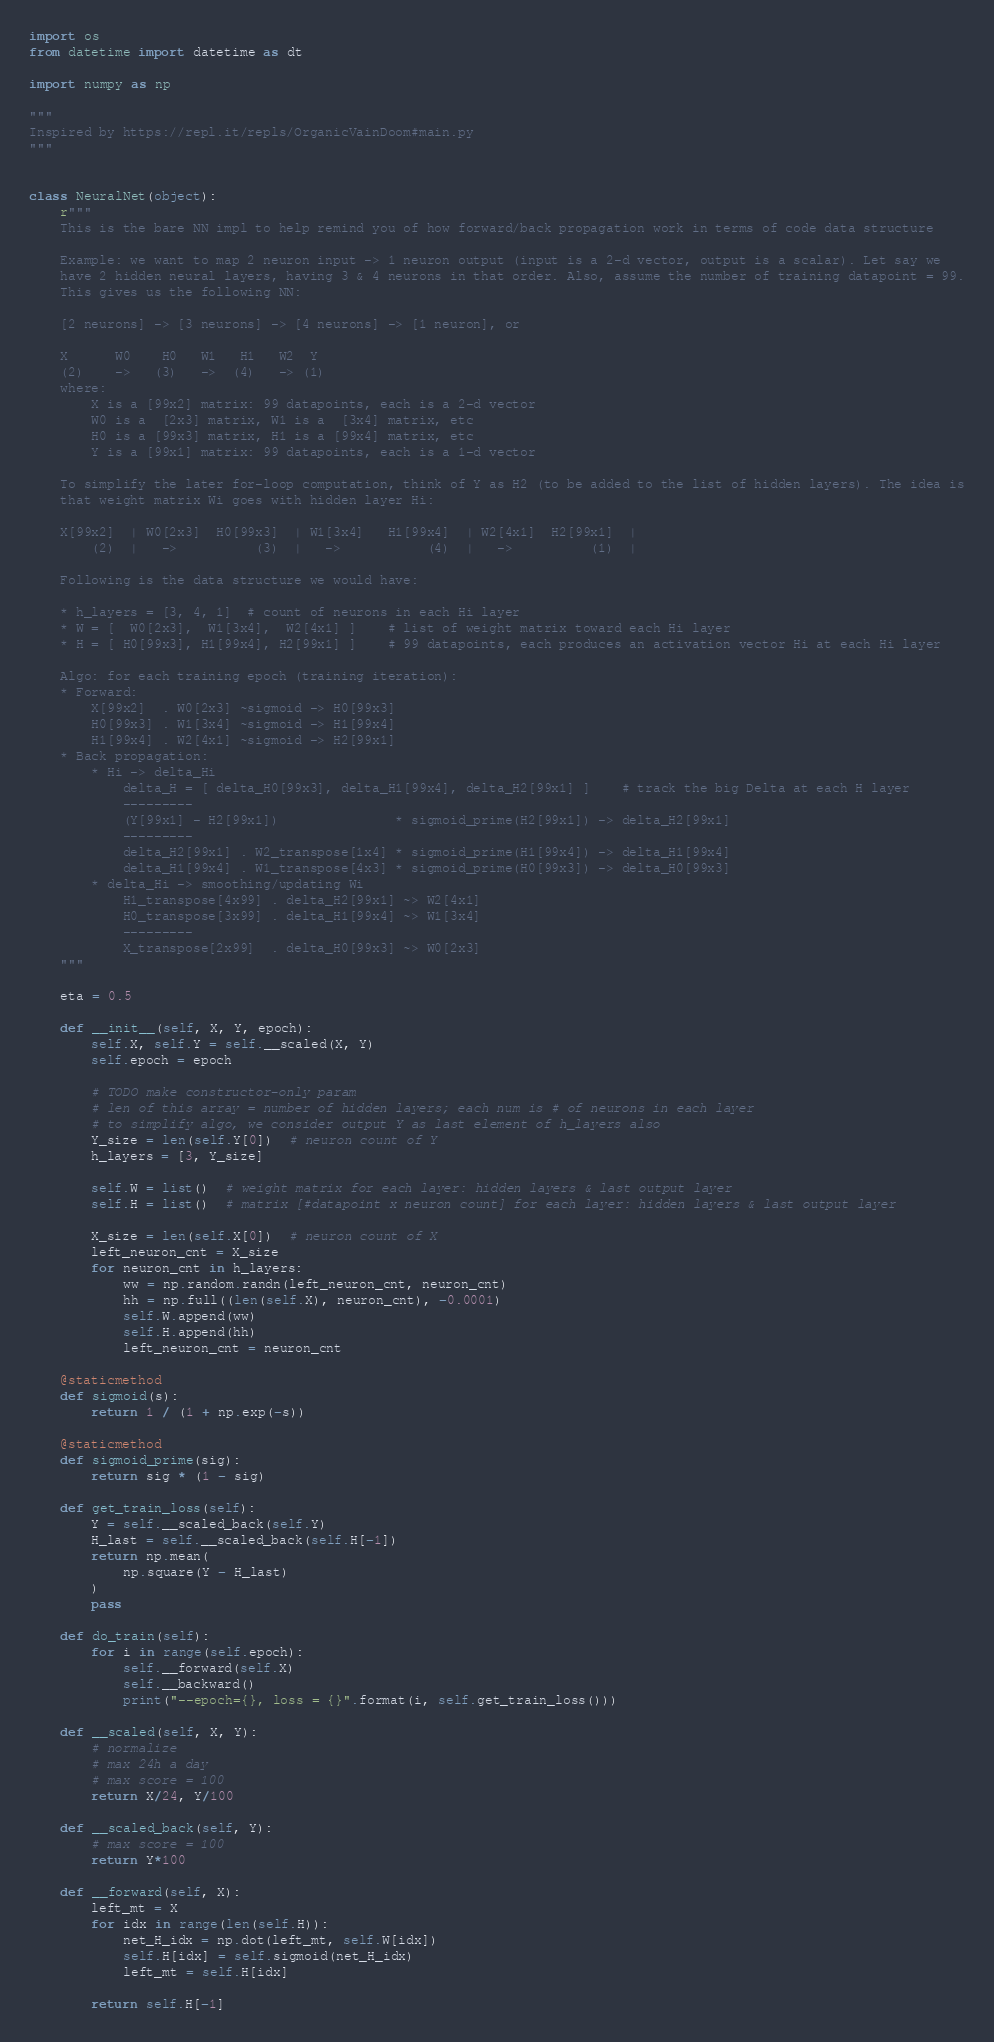Convert code to text. <code><loc_0><loc_0><loc_500><loc_500><_Python_>import os
from datetime import datetime as dt

import numpy as np

"""
Inspired by https://repl.it/repls/OrganicVainDoom#main.py
"""


class NeuralNet(object):
    r"""
    This is the bare NN impl to help remind you of how forward/back propagation work in terms of code data structure

    Example: we want to map 2 neuron input -> 1 neuron output (input is a 2-d vector, output is a scalar). Let say we
    have 2 hidden neural layers, having 3 & 4 neurons in that order. Also, assume the number of training datapoint = 99.
    This gives us the following NN:

    [2 neurons] -> [3 neurons] -> [4 neurons] -> [1 neuron], or

    X      W0    H0   W1   H1   W2  Y
    (2)    ->   (3)   ->  (4)   -> (1)
    where:
        X is a [99x2] matrix: 99 datapoints, each is a 2-d vector
        W0 is a  [2x3] matrix, W1 is a  [3x4] matrix, etc
        H0 is a [99x3] matrix, H1 is a [99x4] matrix, etc
        Y is a [99x1] matrix: 99 datapoints, each is a 1-d vector

    To simplify the later for-loop computation, think of Y as H2 (to be added to the list of hidden layers). The idea is
    that weight matrix Wi goes with hidden layer Hi:

    X[99x2]  | W0[2x3]  H0[99x3]  | W1[3x4]   H1[99x4]  | W2[4x1]  H2[99x1]  |
        (2)  |   ->          (3)  |   ->           (4)  |   ->          (1)  |

    Following is the data structure we would have:

    * h_layers = [3, 4, 1]  # count of neurons in each Hi layer
    * W = [  W0[2x3],  W1[3x4],  W2[4x1] ]    # list of weight matrix toward each Hi layer
    * H = [ H0[99x3], H1[99x4], H2[99x1] ]    # 99 datapoints, each produces an activation vector Hi at each Hi layer

    Algo: for each training epoch (training iteration):
    * Forward:
        X[99x2]  . W0[2x3] ~sigmoid -> H0[99x3]
        H0[99x3] . W1[3x4] ~sigmoid -> H1[99x4]
        H1[99x4] . W2[4x1] ~sigmoid -> H2[99x1]
    * Back propagation:
        * Hi -> delta_Hi
            delta_H = [ delta_H0[99x3], delta_H1[99x4], delta_H2[99x1] ]    # track the big Delta at each H layer
            ---------
            (Y[99x1] - H2[99x1])               * sigmoid_prime(H2[99x1]) -> delta_H2[99x1]
            ---------
            delta_H2[99x1] . W2_transpose[1x4] * sigmoid_prime(H1[99x4]) -> delta_H1[99x4]
            delta_H1[99x4] . W1_transpose[4x3] * sigmoid_prime(H0[99x3]) -> delta_H0[99x3]
        * delta_Hi -> smoothing/updating Wi
            H1_transpose[4x99] . delta_H2[99x1] ~> W2[4x1]
            H0_transpose[3x99] . delta_H1[99x4] ~> W1[3x4]
            ---------
            X_transpose[2x99]  . delta_H0[99x3] ~> W0[2x3]
    """

    eta = 0.5

    def __init__(self, X, Y, epoch):
        self.X, self.Y = self.__scaled(X, Y)
        self.epoch = epoch

        # TODO make constructor-only param
        # len of this array = number of hidden layers; each num is # of neurons in each layer
        # to simplify algo, we consider output Y as last element of h_layers also
        Y_size = len(self.Y[0])  # neuron count of Y
        h_layers = [3, Y_size]

        self.W = list()  # weight matrix for each layer: hidden layers & last output layer
        self.H = list()  # matrix [#datapoint x neuron count] for each layer: hidden layers & last output layer

        X_size = len(self.X[0])  # neuron count of X
        left_neuron_cnt = X_size
        for neuron_cnt in h_layers:
            ww = np.random.randn(left_neuron_cnt, neuron_cnt)
            hh = np.full((len(self.X), neuron_cnt), -0.0001)
            self.W.append(ww)
            self.H.append(hh)
            left_neuron_cnt = neuron_cnt

    @staticmethod
    def sigmoid(s):
        return 1 / (1 + np.exp(-s))

    @staticmethod
    def sigmoid_prime(sig):
        return sig * (1 - sig)

    def get_train_loss(self):
        Y = self.__scaled_back(self.Y)
        H_last = self.__scaled_back(self.H[-1])
        return np.mean(
            np.square(Y - H_last)
        )
        pass

    def do_train(self):
        for i in range(self.epoch):
            self.__forward(self.X)
            self.__backward()
            print("--epoch={}, loss = {}".format(i, self.get_train_loss()))

    def __scaled(self, X, Y):
        # normalize
        # max 24h a day
        # max score = 100
        return X/24, Y/100

    def __scaled_back(self, Y):
        # max score = 100
        return Y*100

    def __forward(self, X):
        left_mt = X
        for idx in range(len(self.H)):
            net_H_idx = np.dot(left_mt, self.W[idx])
            self.H[idx] = self.sigmoid(net_H_idx)
            left_mt = self.H[idx]

        return self.H[-1]
</code> 